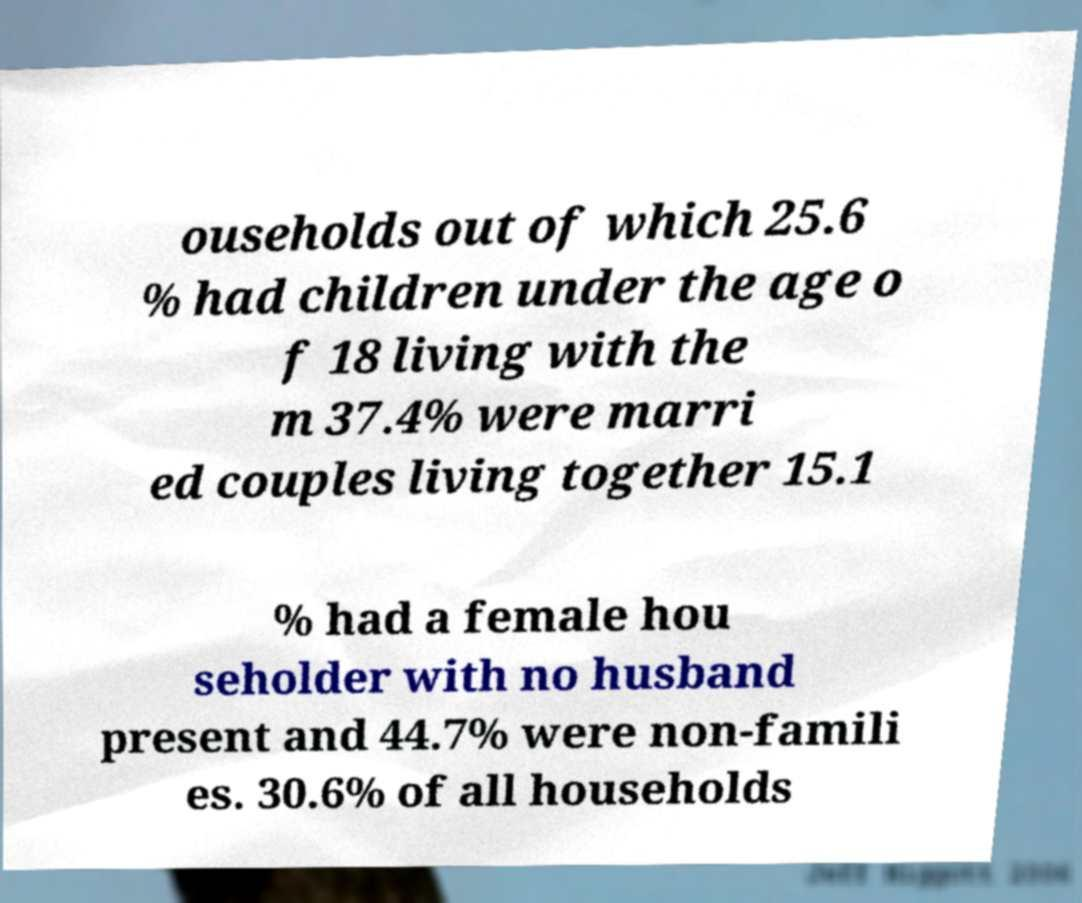Could you assist in decoding the text presented in this image and type it out clearly? ouseholds out of which 25.6 % had children under the age o f 18 living with the m 37.4% were marri ed couples living together 15.1 % had a female hou seholder with no husband present and 44.7% were non-famili es. 30.6% of all households 